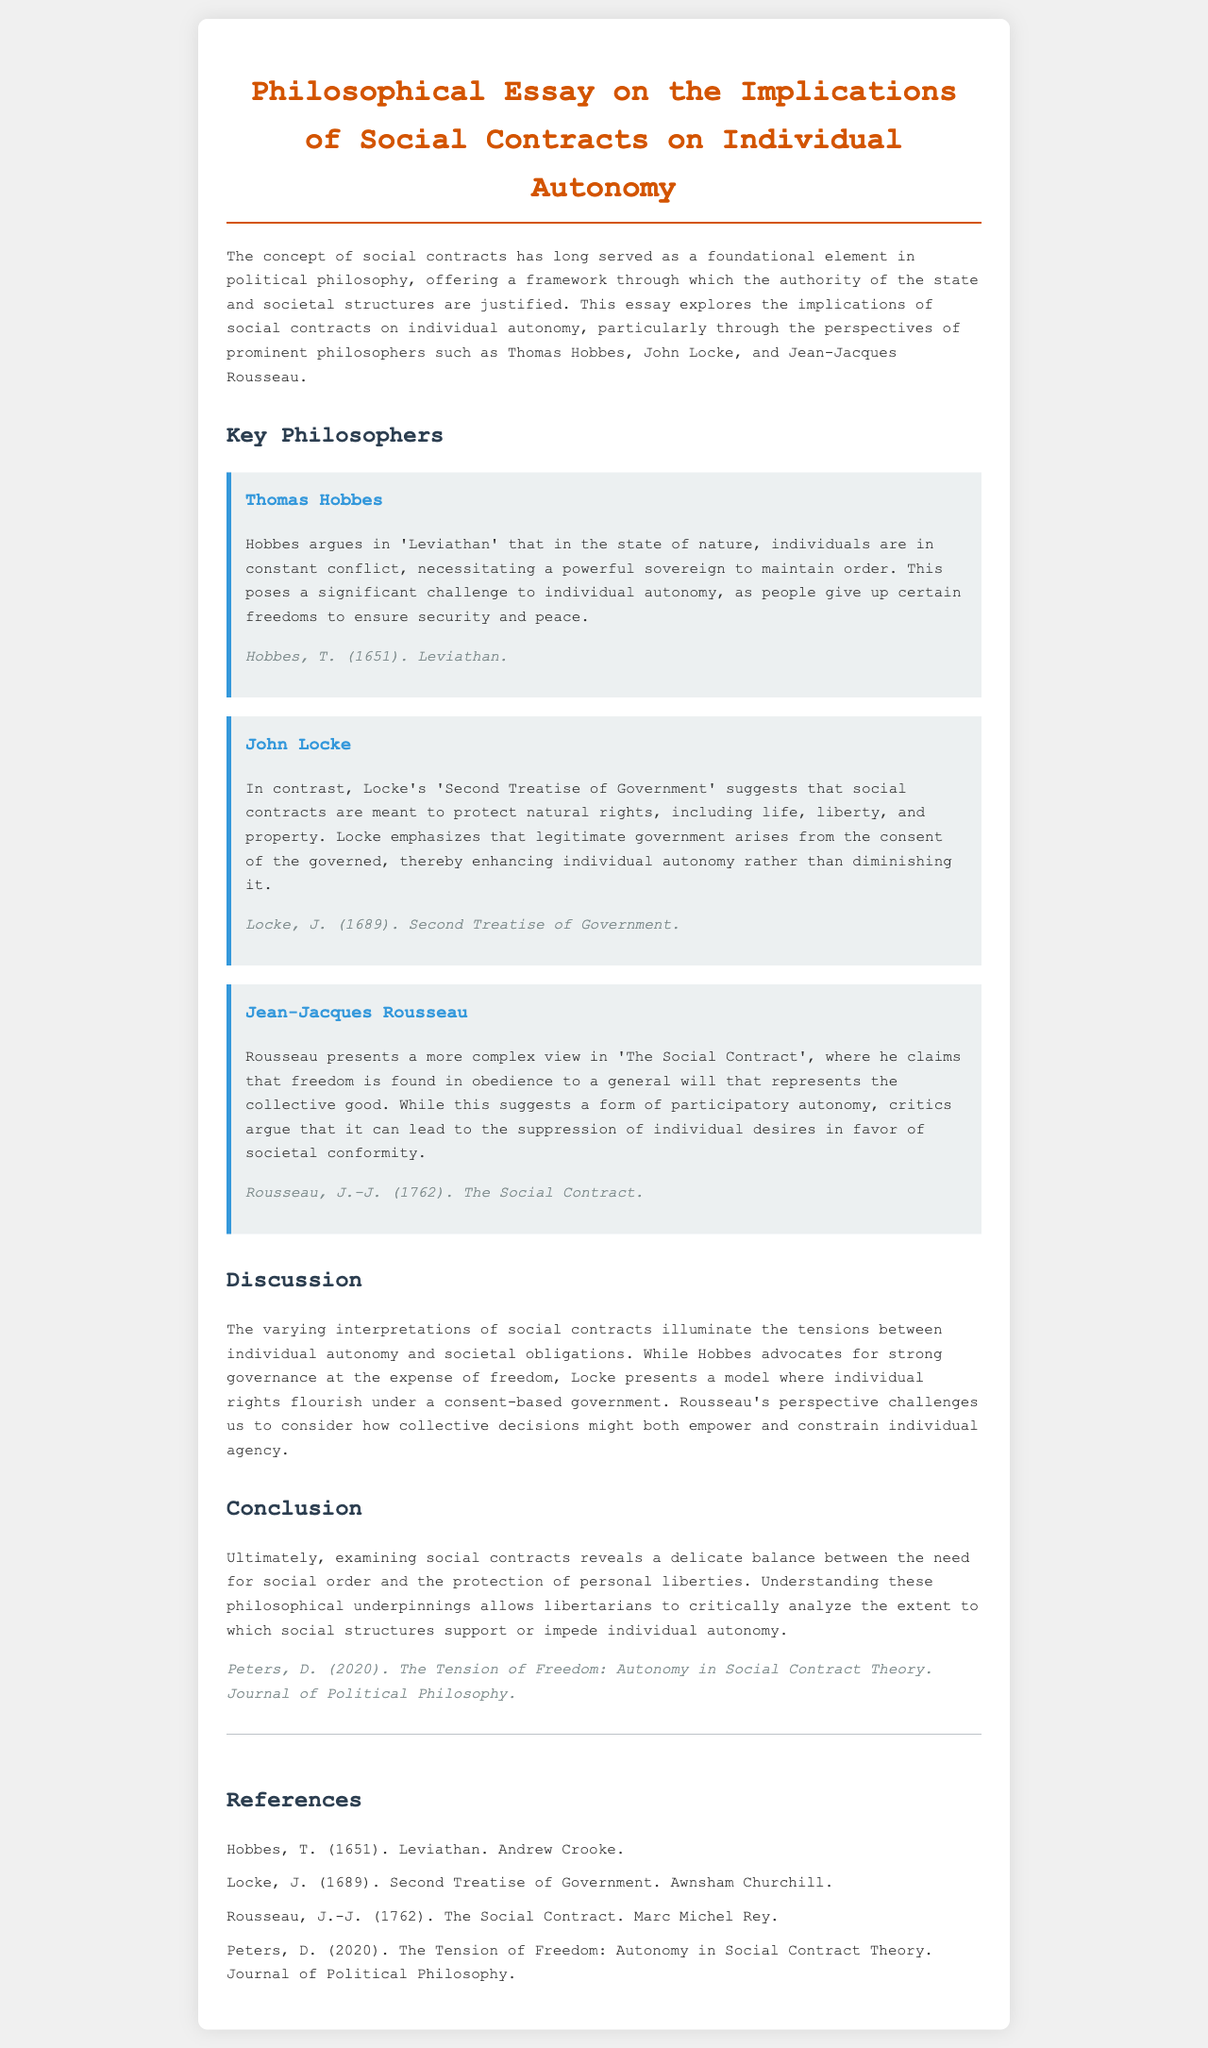What is the title of the essay? The title of the essay is prominently displayed at the top of the document, summarizing its main topic.
Answer: Philosophical Essay on the Implications of Social Contracts on Individual Autonomy Who is the first philosopher discussed in the essay? The essay introduces three philosophers, and the first one mentioned is listed clearly in a section dedicated to key philosophers.
Answer: Thomas Hobbes What year was "Leviathan" published? The publication year of Hobbes' work is provided in parentheses after his name and analysis in the document.
Answer: 1651 How does John Locke view social contracts? Locke's perspective on social contracts is articulated in a specific paragraph that focuses on his beliefs, making it clear.
Answer: Protect natural rights What is Rousseau's view of freedom? Rousseau's explanation of freedom is detailed in his section, providing insight into his philosophical stance.
Answer: Obedience to a general will Which philosopher emphasizes the consent of the governed? The document indicates that one philosopher specifically addresses the importance of consent in relation to governance.
Answer: John Locke What is the main theme discussed in the conclusion? The conclusion highlights the overarching topic of the essay, as stated in the closing remarks.
Answer: Balance between social order and personal liberties Who wrote "The Tension of Freedom"? The reference section lists authors and their works, and this title is attributed to a particular author.
Answer: D. Peters What type of government does Hobbes advocate for? The essay summarizes Hobbes' argument regarding governance in a straightforward manner, directly mentioning the type he supports.
Answer: Powerful sovereign 